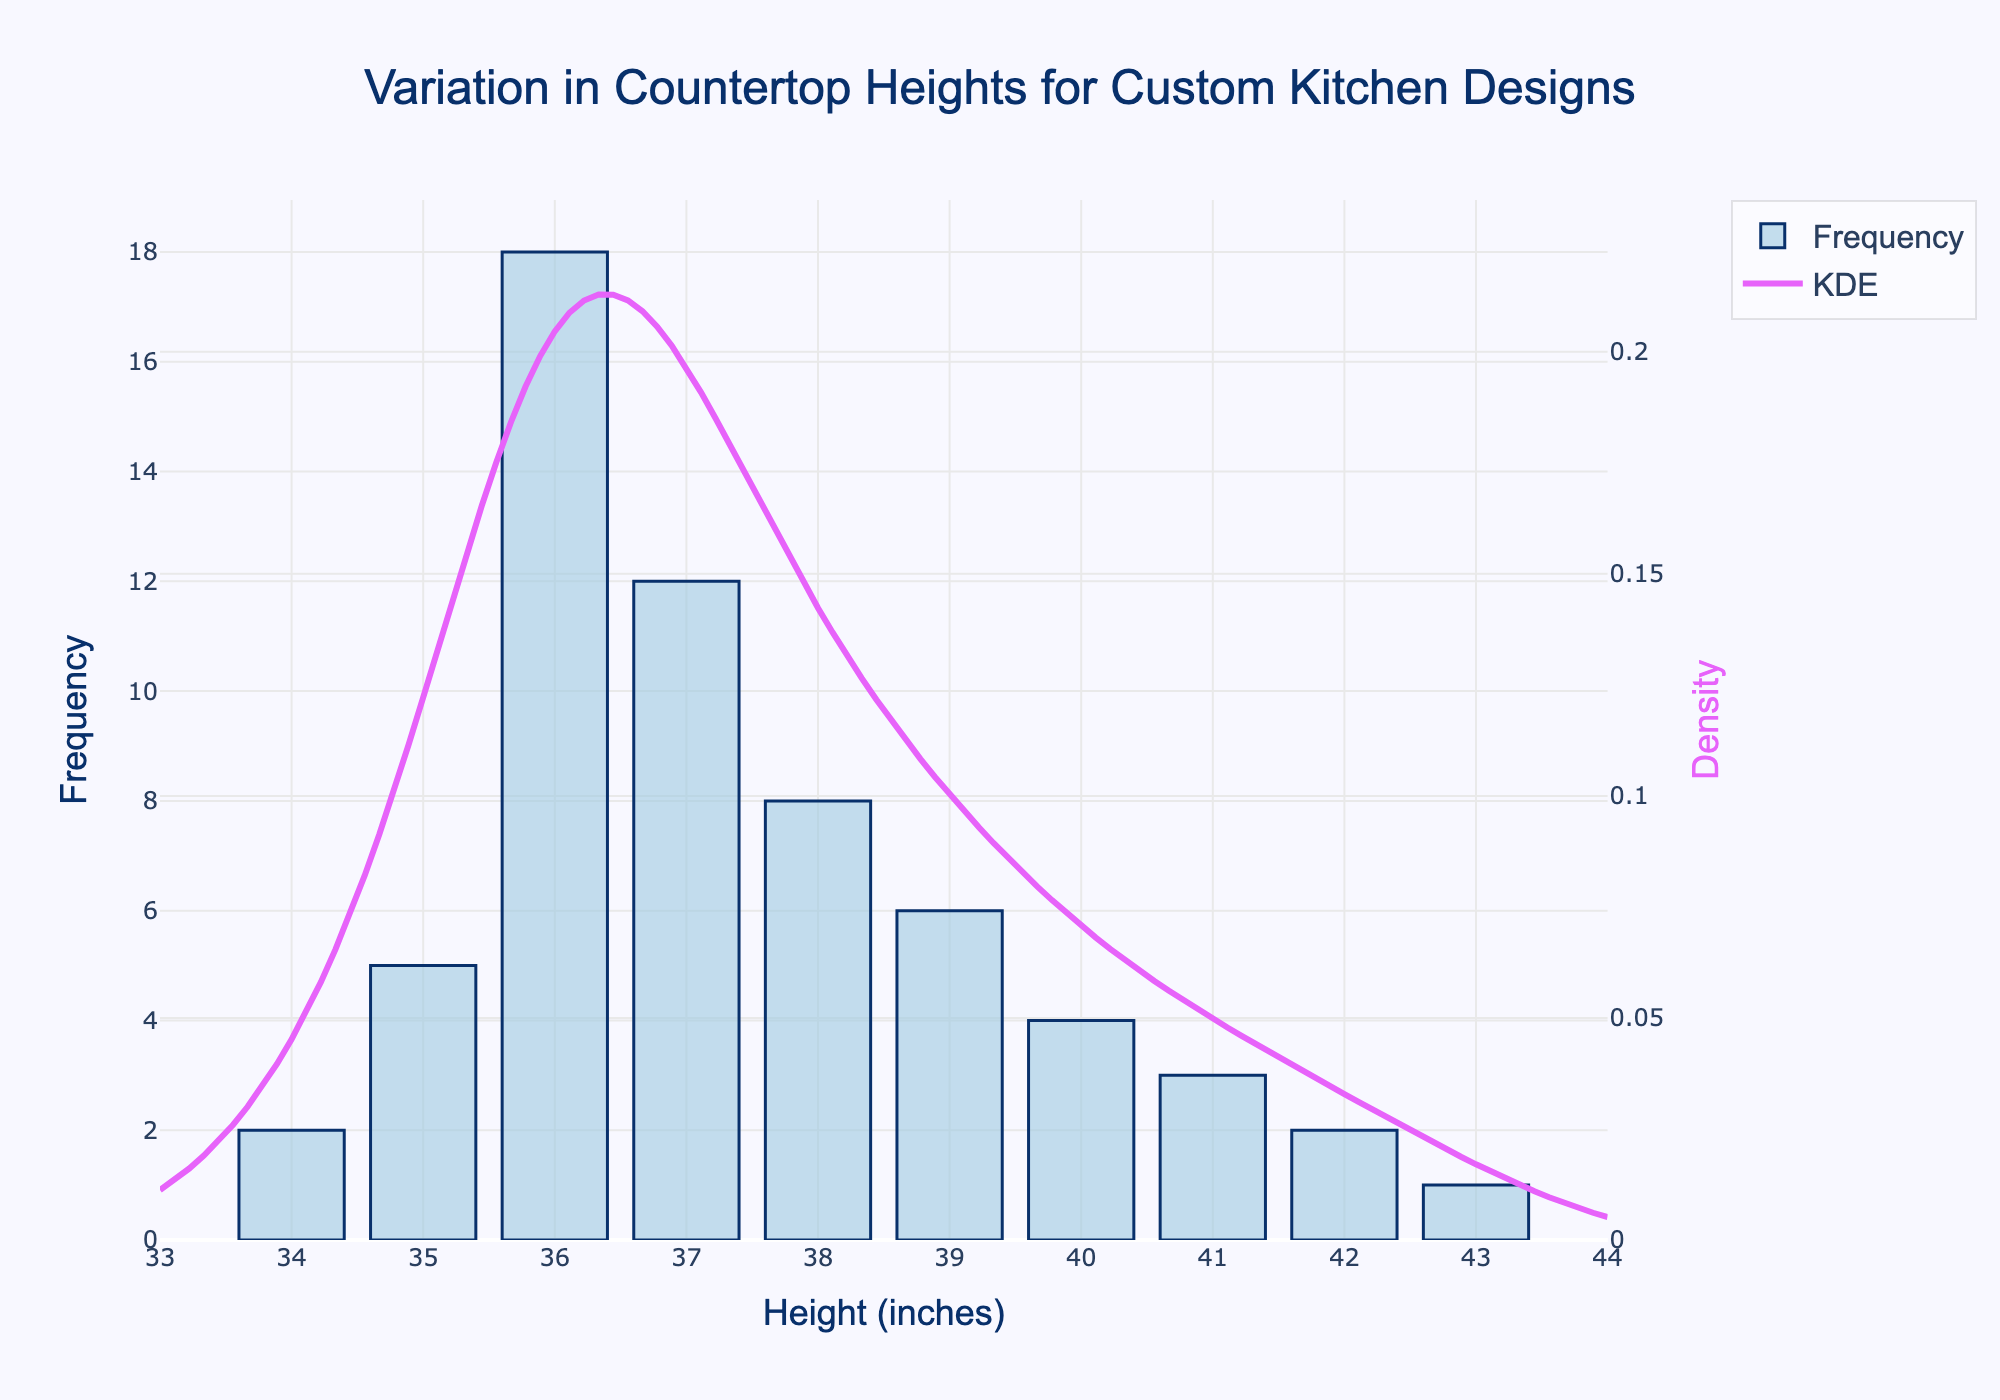What is the title of the plot? The title is positioned at the top center of the plot and reads: "Variation in Countertop Heights for Custom Kitchen Designs".
Answer: Variation in Countertop Heights for Custom Kitchen Designs What does the X-axis represent? The X-axis label is "Height (inches)," which indicates it represents the different heights of countertops in inches.
Answer: Height (inches) How many countertop heights have a frequency of more than 10? By scanning the histogram bars, frequencies of more than 10 are observed for heights of 36 inches (18) and 37 inches (12).
Answer: 2 Between which heights does the density curve (KDE) peak? The KDE curve peaks between the heights of 36 inches and 37 inches, which corresponds to the highest frequencies observed in the histogram.
Answer: 36 and 37 inches What is the most frequent countertop height? The highest bar in the histogram indicates the most frequent countertop height is 36 inches with a frequency of 18.
Answer: 36 inches How does the density of countertop heights change as height increases? Observing the KDE curve, it starts high at 36 inches, peaks around 37 inches, and then gradually decreases as the height increases beyond 37 inches.
Answer: Decreases after peaking What is the frequency of the tallest countertop height recorded? From the histogram, the tallest height recorded is 43 inches, and its frequency is 1.
Answer: 1 Compare the frequencies of countertop heights at 38 inches and 39 inches. Which one is more frequent? The bar corresponding to 38 inches has a frequency of 8, while the bar for 39 inches has a frequency of 6, indicating 38 inches is more frequent.
Answer: 38 inches Which countertop heights have a frequency of exactly 2? By analyzing the histogram, the countertop heights of 34 inches and 42 inches each have a frequency of 2.
Answer: 34 inches and 42 inches What can you infer about the ergonomic considerations based on the KDE curve? The high peak around 36-37 inches indicates most countertops are designed within this range, likely for optimal ergonomic convenience, as it represents the common countertop height for comfortable use.
Answer: 36-37 inches optimal for ergonomics 